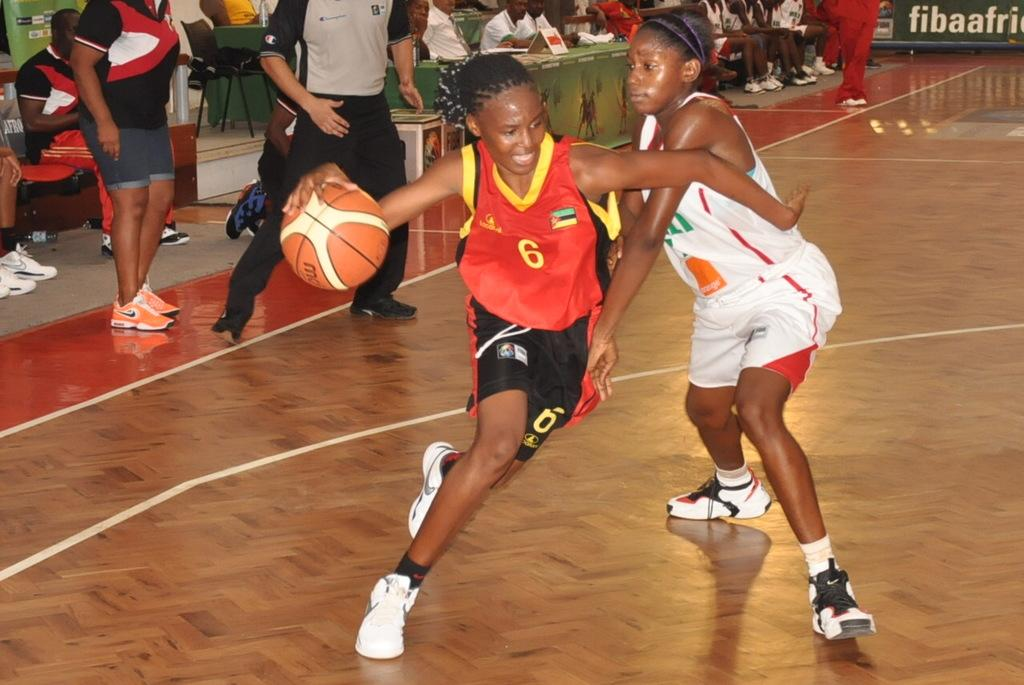<image>
Relay a brief, clear account of the picture shown. a basetball game with one of the players wearing uniform number 6 